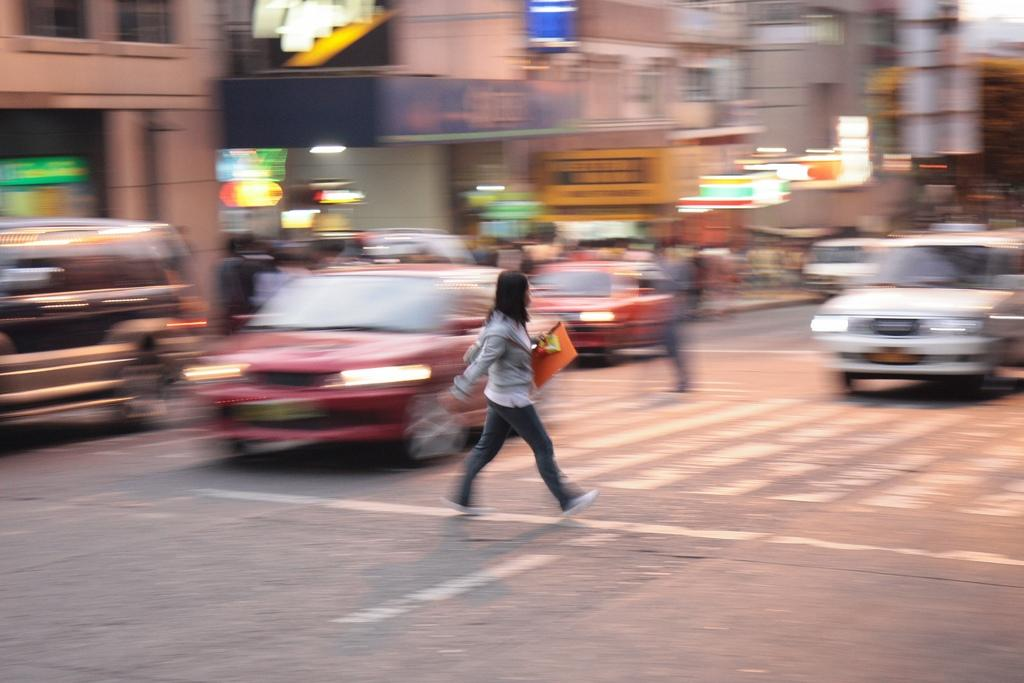What is the person in the image doing? The person is walking in the image. On what surface is the person walking? The person is walking on a road. Are there any vehicles present in the image? Yes, there are cars moving on the road. What can be seen in the background of the image? There are buildings and lights visible in the background. What type of yarn is being used to create the brick pattern on the person's shirt in the image? There is no mention of a shirt or a brick pattern in the image, nor is there any yarn present. 